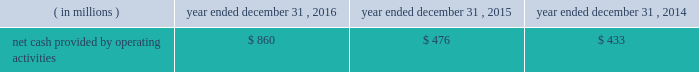Special purpose entity ( 201cspe 201d ) .
The spe obtained a term loan and revolving loan commitment from a third party lender , secured by liens on the assets of the spe , to finance the purchase of the accounts receivable , which included a $ 275 million term loan and a $ 25 million revolving loan commitment .
The revolving loan commitment may be increased by an additional $ 35 million as amounts are repaid under the term loan .
Quintilesims has guaranteed the performance of the obligations of existing and future subsidiaries that sell and service the accounts receivable under the receivables financing facility .
The assets of the spe are not available to satisfy any of our obligations or any obligations of our subsidiaries .
As of december 31 , 2016 , the full $ 25 million of revolving loan commitment was available under the receivables financing facility .
We used the proceeds from the term loan under the receivables financing facility to repay in full the amount outstanding on the then outstanding revolving credit facility under its then outstanding senior secured credit agreement ( $ 150 million ) , to repay $ 25 million of the then outstanding term loan b-3 , to pay related fees and expenses and the remainder was used for general working capital purposes .
Restrictive covenants our debt agreements provide for certain covenants and events of default customary for similar instruments , including a covenant not to exceed a specified ratio of consolidated senior secured net indebtedness to consolidated ebitda , as defined in the senior secured credit facility and a covenant to maintain a specified minimum interest coverage ratio .
If an event of default occurs under any of the company 2019s or the company 2019s subsidiaries 2019 financing arrangements , the creditors under such financing arrangements will be entitled to take various actions , including the acceleration of amounts due under such arrangements , and in the case of the lenders under the revolving credit facility and new term loans , other actions permitted to be taken by a secured creditor .
Our long-term debt arrangements contain usual and customary restrictive covenants that , among other things , place limitations on our ability to declare dividends .
For additional information regarding these restrictive covenants , see part ii , item 5 201cmarket for registrant 2019s common equity , related stockholder matters and issuer purchases of equity securities 2014dividend policy 201d and note 11 to our audited consolidated financial statements included elsewhere in this annual report on form 10-k .
At december 31 , 2016 , the company was in compliance with the financial covenants under the company 2019s financing arrangements .
Years ended december 31 , 2016 , 2015 and 2014 cash flow from operating activities .
2016 compared to 2015 cash provided by operating activities increased $ 384 million in 2016 as compared to 2015 .
The increase in cash provided by operating activities reflects the increase in net income as adjusted for non-cash items necessary to reconcile net income to cash provided by operating activities .
Also contributing to the increase were lower payments for income taxes ( $ 15 million ) , and lower cash used in days sales outstanding ( 201cdso 201d ) and accounts payable and accrued expenses .
The lower cash used in dso reflects a two-day increase in dso in 2016 compared to a seven-day increase in dso in 2015 .
Dso can shift significantly at each reporting period depending on the timing of cash receipts under contractual payment terms relative to the recognition of revenue over a project lifecycle. .
What was the percentage change in the net cash provided by operating activities in 2016? 
Computations: (384 / 476)
Answer: 0.80672. 